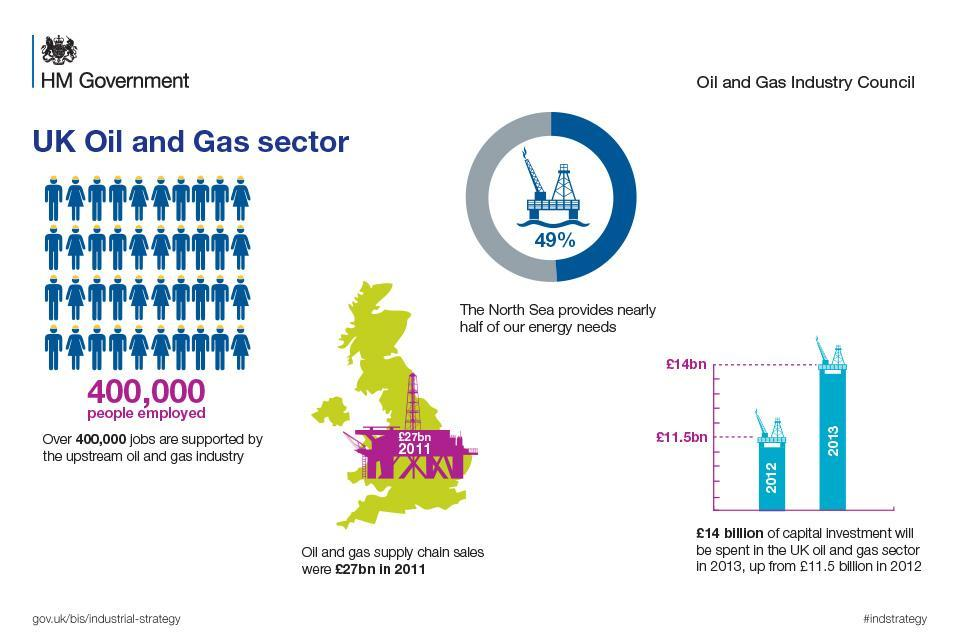What is the exact share of north seas contribution to energy needs?
Answer the question with a short phrase. 49% How many billionss of capital investment (in pounds) was there in oil and gas sector in 2012? 11.5 